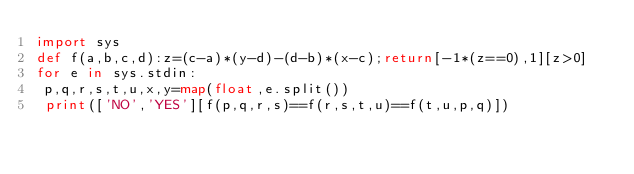<code> <loc_0><loc_0><loc_500><loc_500><_Python_>import sys
def f(a,b,c,d):z=(c-a)*(y-d)-(d-b)*(x-c);return[-1*(z==0),1][z>0]
for e in sys.stdin:
 p,q,r,s,t,u,x,y=map(float,e.split())
 print(['NO','YES'][f(p,q,r,s)==f(r,s,t,u)==f(t,u,p,q)])

</code> 